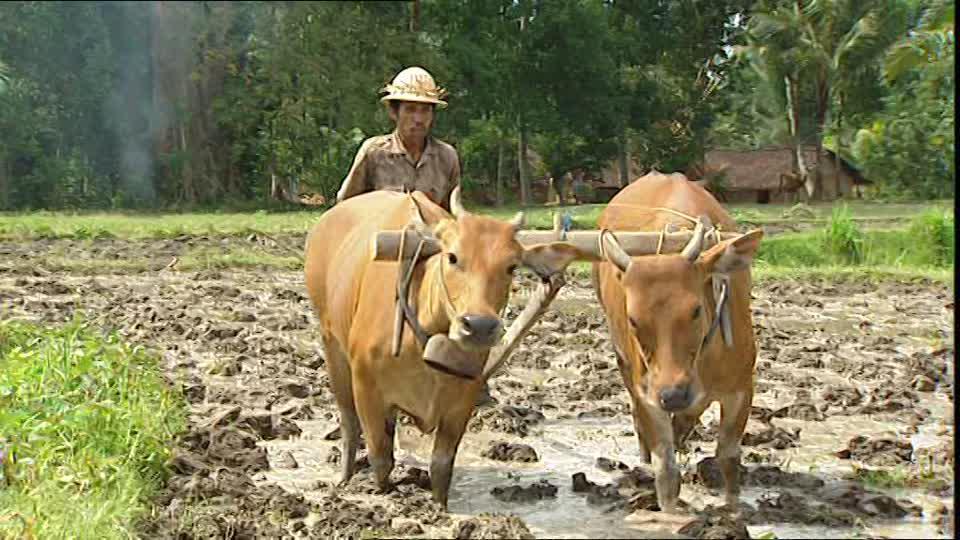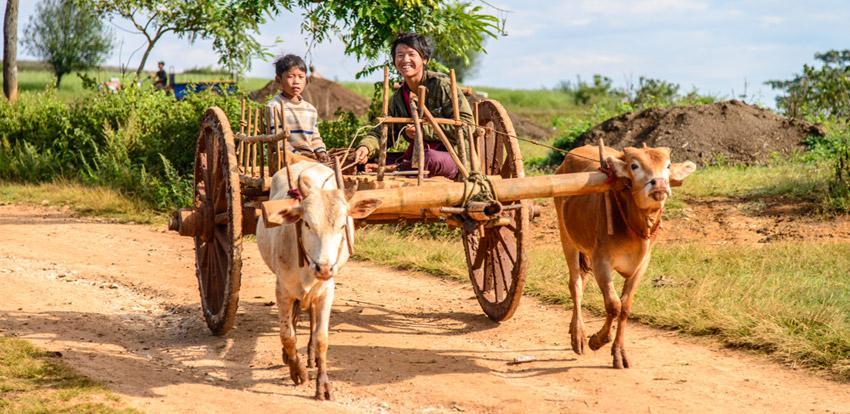The first image is the image on the left, the second image is the image on the right. Evaluate the accuracy of this statement regarding the images: "Ox are pulling a cart with wheels.". Is it true? Answer yes or no. Yes. The first image is the image on the left, the second image is the image on the right. Evaluate the accuracy of this statement regarding the images: "One image shows two oxen pulling a two-wheeled cart forward on a road, and the other image shows a man standing behind a team of two oxen pulling a plow on a dirt-turned field.". Is it true? Answer yes or no. Yes. 